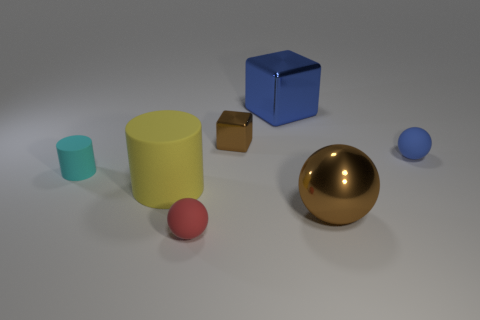Add 1 tiny cyan matte objects. How many objects exist? 8 Subtract all blue rubber spheres. How many spheres are left? 2 Subtract all cylinders. How many objects are left? 5 Subtract all cyan cubes. How many yellow balls are left? 0 Subtract all blue metallic things. Subtract all big blue objects. How many objects are left? 5 Add 7 big brown objects. How many big brown objects are left? 8 Add 5 big brown rubber spheres. How many big brown rubber spheres exist? 5 Subtract all brown spheres. How many spheres are left? 2 Subtract 0 purple blocks. How many objects are left? 7 Subtract 1 spheres. How many spheres are left? 2 